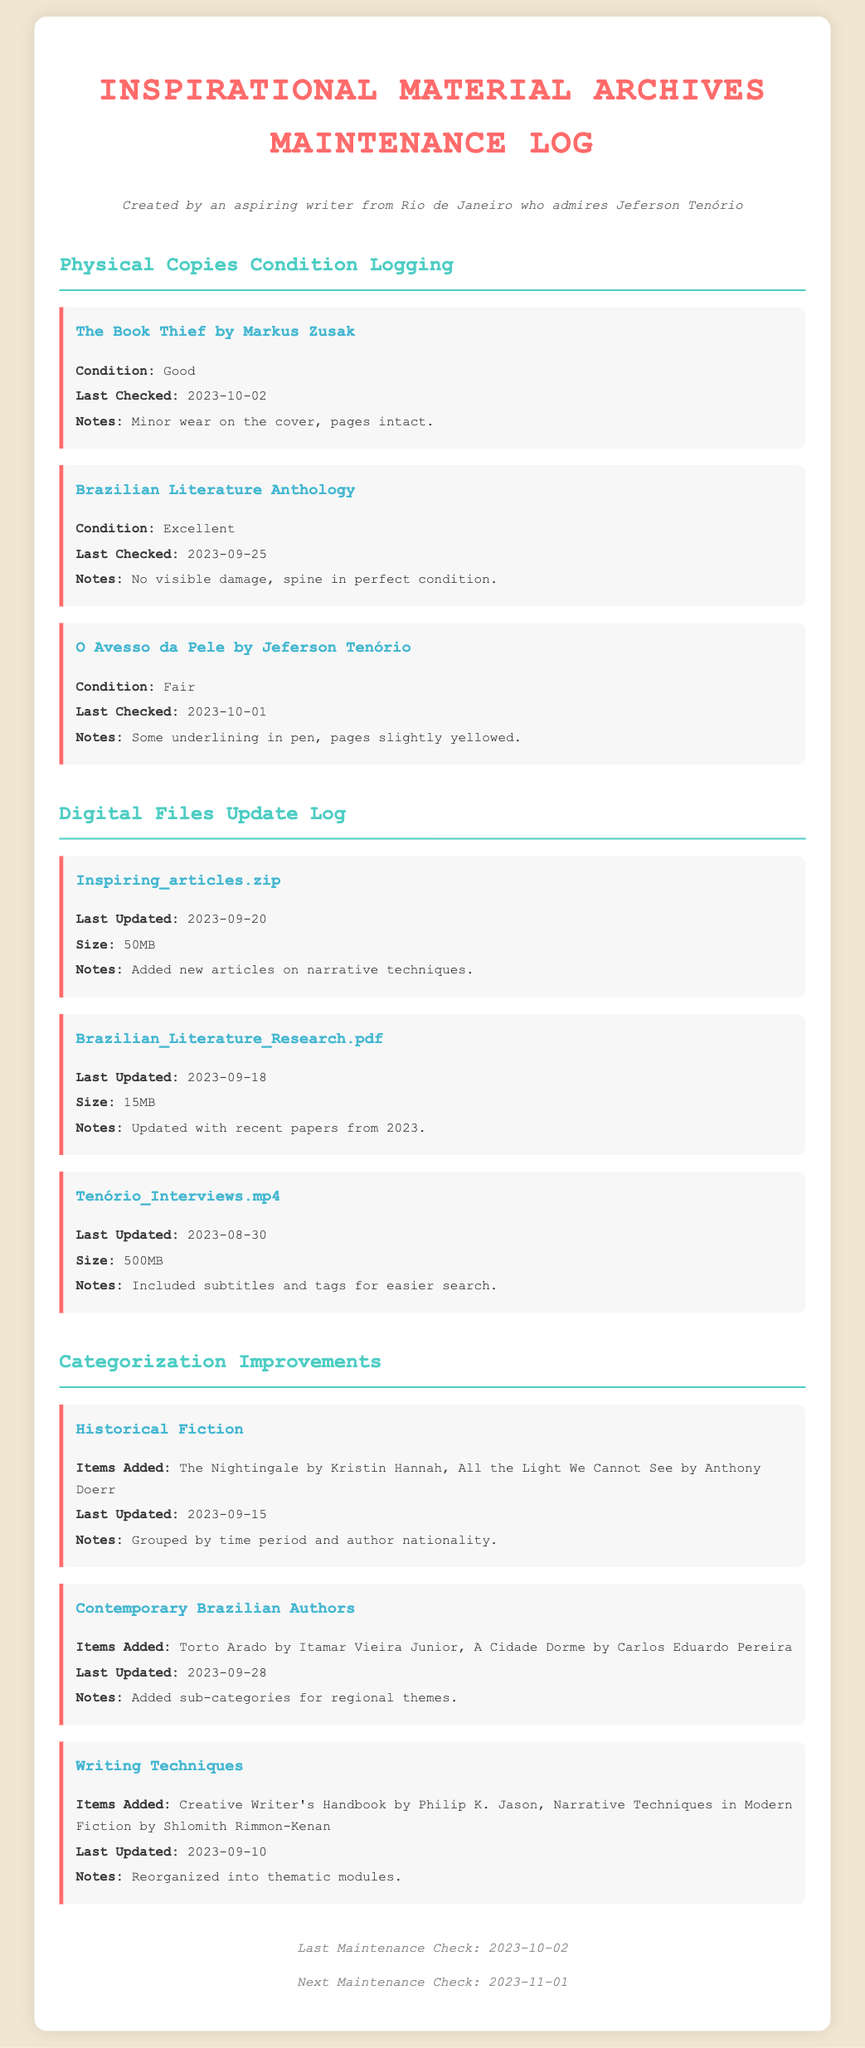what is the condition of "O Avesso da Pele"? The condition is logged in the maintenance log as "Fair".
Answer: Fair when was the last check for "The Book Thief"? The document specifies that the last check for "The Book Thief" was on 2023-10-02.
Answer: 2023-10-02 how many items were added to the "Contemporary Brazilian Authors" category? The log states items added as "Torto Arado by Itamar Vieira Junior, A Cidade Dorme by Carlos Eduardo Pereira", indicating two items.
Answer: Two what file size is noted for "Tenório_Interviews.mp4"? The document mentions the file size of "Tenório_Interviews.mp4" as "500MB".
Answer: 500MB what is the last updated date for the "Inspiring_articles.zip"? The document states that "Inspiring_articles.zip" was last updated on 2023-09-20.
Answer: 2023-09-20 which famous author’s book is logged with minor wear on the cover? The log indicates that "The Book Thief" by Markus Zusak is noted to have minor wear on the cover.
Answer: "The Book Thief" by Markus Zusak what are the notes for the "Brazilian Literature Anthology"? The log details that the notes state "No visible damage, spine in perfect condition."
Answer: No visible damage, spine in perfect condition when is the next maintenance check scheduled? According to the footer of the document, the next maintenance check is scheduled for 2023-11-01.
Answer: 2023-11-01 